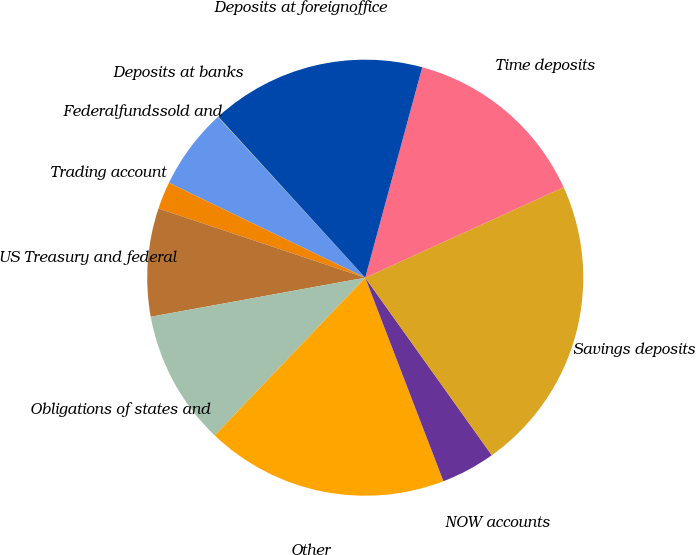Convert chart. <chart><loc_0><loc_0><loc_500><loc_500><pie_chart><fcel>Deposits at banks<fcel>Federalfundssold and<fcel>Trading account<fcel>US Treasury and federal<fcel>Obligations of states and<fcel>Other<fcel>NOW accounts<fcel>Savings deposits<fcel>Time deposits<fcel>Deposits at foreignoffice<nl><fcel>0.04%<fcel>6.02%<fcel>2.03%<fcel>8.01%<fcel>10.0%<fcel>17.97%<fcel>4.02%<fcel>21.95%<fcel>13.98%<fcel>15.98%<nl></chart> 